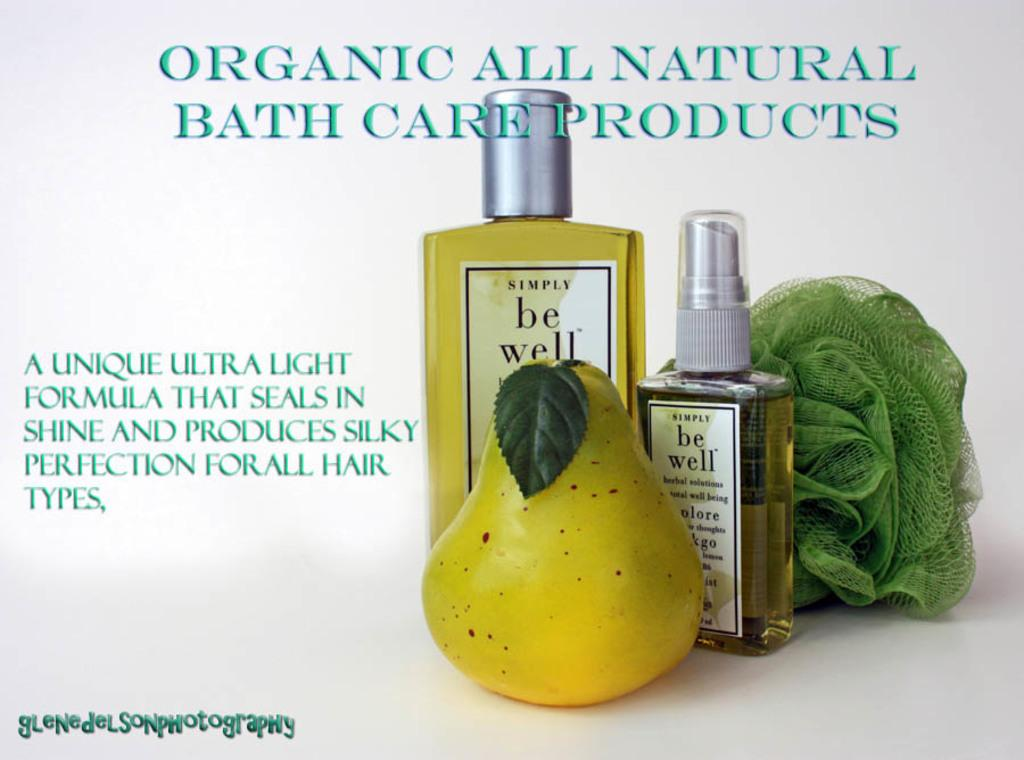<image>
Present a compact description of the photo's key features. ad for organic all natural bath care products  with spray bottles, a pear, and green luffa sponge 